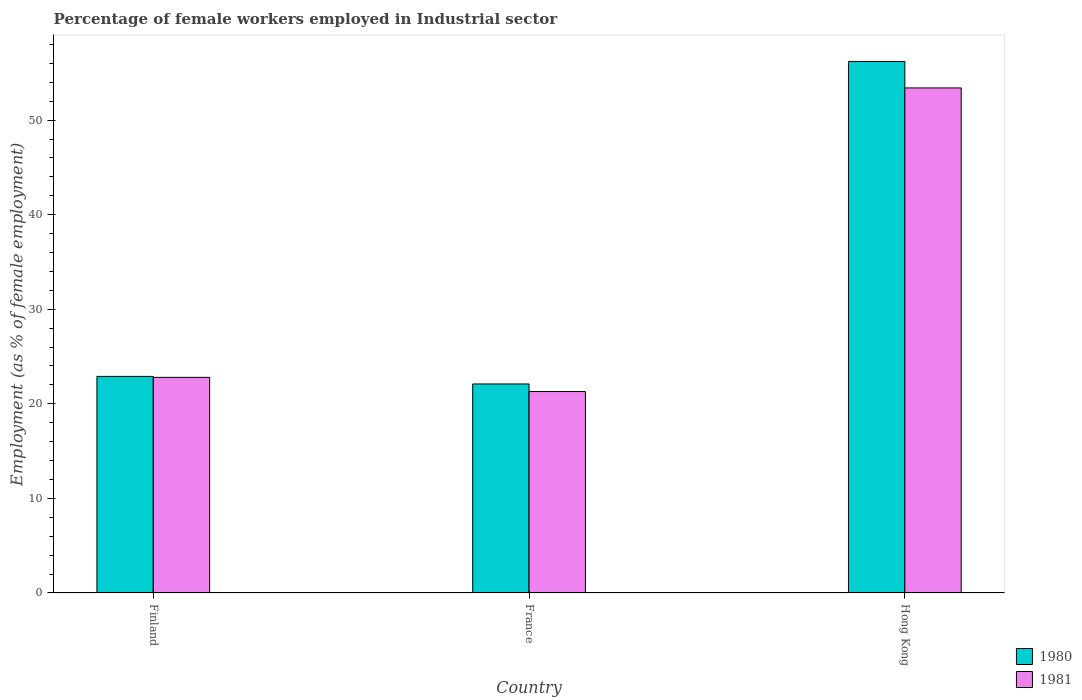How many bars are there on the 1st tick from the left?
Ensure brevity in your answer.  2. How many bars are there on the 1st tick from the right?
Keep it short and to the point. 2. In how many cases, is the number of bars for a given country not equal to the number of legend labels?
Ensure brevity in your answer.  0. What is the percentage of females employed in Industrial sector in 1981 in Finland?
Offer a very short reply. 22.8. Across all countries, what is the maximum percentage of females employed in Industrial sector in 1980?
Provide a short and direct response. 56.2. Across all countries, what is the minimum percentage of females employed in Industrial sector in 1981?
Offer a terse response. 21.3. In which country was the percentage of females employed in Industrial sector in 1981 maximum?
Offer a very short reply. Hong Kong. What is the total percentage of females employed in Industrial sector in 1980 in the graph?
Your response must be concise. 101.2. What is the difference between the percentage of females employed in Industrial sector in 1981 in France and that in Hong Kong?
Ensure brevity in your answer.  -32.1. What is the difference between the percentage of females employed in Industrial sector in 1980 in France and the percentage of females employed in Industrial sector in 1981 in Finland?
Your response must be concise. -0.7. What is the average percentage of females employed in Industrial sector in 1980 per country?
Keep it short and to the point. 33.73. What is the difference between the percentage of females employed in Industrial sector of/in 1980 and percentage of females employed in Industrial sector of/in 1981 in Hong Kong?
Your response must be concise. 2.8. In how many countries, is the percentage of females employed in Industrial sector in 1981 greater than 10 %?
Give a very brief answer. 3. What is the ratio of the percentage of females employed in Industrial sector in 1980 in Finland to that in Hong Kong?
Provide a short and direct response. 0.41. Is the percentage of females employed in Industrial sector in 1981 in Finland less than that in Hong Kong?
Provide a succinct answer. Yes. What is the difference between the highest and the second highest percentage of females employed in Industrial sector in 1981?
Offer a very short reply. -32.1. What is the difference between the highest and the lowest percentage of females employed in Industrial sector in 1981?
Your answer should be compact. 32.1. What does the 2nd bar from the left in France represents?
Your response must be concise. 1981. What does the 1st bar from the right in France represents?
Offer a terse response. 1981. How many bars are there?
Your answer should be compact. 6. Does the graph contain any zero values?
Your answer should be very brief. No. Does the graph contain grids?
Offer a terse response. No. What is the title of the graph?
Keep it short and to the point. Percentage of female workers employed in Industrial sector. Does "1963" appear as one of the legend labels in the graph?
Your answer should be very brief. No. What is the label or title of the Y-axis?
Offer a very short reply. Employment (as % of female employment). What is the Employment (as % of female employment) in 1980 in Finland?
Give a very brief answer. 22.9. What is the Employment (as % of female employment) of 1981 in Finland?
Make the answer very short. 22.8. What is the Employment (as % of female employment) of 1980 in France?
Offer a very short reply. 22.1. What is the Employment (as % of female employment) in 1981 in France?
Offer a terse response. 21.3. What is the Employment (as % of female employment) in 1980 in Hong Kong?
Keep it short and to the point. 56.2. What is the Employment (as % of female employment) in 1981 in Hong Kong?
Your response must be concise. 53.4. Across all countries, what is the maximum Employment (as % of female employment) in 1980?
Ensure brevity in your answer.  56.2. Across all countries, what is the maximum Employment (as % of female employment) in 1981?
Provide a short and direct response. 53.4. Across all countries, what is the minimum Employment (as % of female employment) in 1980?
Offer a very short reply. 22.1. Across all countries, what is the minimum Employment (as % of female employment) of 1981?
Offer a very short reply. 21.3. What is the total Employment (as % of female employment) of 1980 in the graph?
Your response must be concise. 101.2. What is the total Employment (as % of female employment) in 1981 in the graph?
Ensure brevity in your answer.  97.5. What is the difference between the Employment (as % of female employment) in 1980 in Finland and that in Hong Kong?
Ensure brevity in your answer.  -33.3. What is the difference between the Employment (as % of female employment) of 1981 in Finland and that in Hong Kong?
Ensure brevity in your answer.  -30.6. What is the difference between the Employment (as % of female employment) of 1980 in France and that in Hong Kong?
Ensure brevity in your answer.  -34.1. What is the difference between the Employment (as % of female employment) in 1981 in France and that in Hong Kong?
Provide a succinct answer. -32.1. What is the difference between the Employment (as % of female employment) of 1980 in Finland and the Employment (as % of female employment) of 1981 in France?
Your response must be concise. 1.6. What is the difference between the Employment (as % of female employment) in 1980 in Finland and the Employment (as % of female employment) in 1981 in Hong Kong?
Give a very brief answer. -30.5. What is the difference between the Employment (as % of female employment) of 1980 in France and the Employment (as % of female employment) of 1981 in Hong Kong?
Your response must be concise. -31.3. What is the average Employment (as % of female employment) in 1980 per country?
Keep it short and to the point. 33.73. What is the average Employment (as % of female employment) in 1981 per country?
Offer a terse response. 32.5. What is the ratio of the Employment (as % of female employment) of 1980 in Finland to that in France?
Keep it short and to the point. 1.04. What is the ratio of the Employment (as % of female employment) in 1981 in Finland to that in France?
Make the answer very short. 1.07. What is the ratio of the Employment (as % of female employment) in 1980 in Finland to that in Hong Kong?
Provide a succinct answer. 0.41. What is the ratio of the Employment (as % of female employment) of 1981 in Finland to that in Hong Kong?
Keep it short and to the point. 0.43. What is the ratio of the Employment (as % of female employment) in 1980 in France to that in Hong Kong?
Ensure brevity in your answer.  0.39. What is the ratio of the Employment (as % of female employment) of 1981 in France to that in Hong Kong?
Your response must be concise. 0.4. What is the difference between the highest and the second highest Employment (as % of female employment) of 1980?
Give a very brief answer. 33.3. What is the difference between the highest and the second highest Employment (as % of female employment) in 1981?
Provide a short and direct response. 30.6. What is the difference between the highest and the lowest Employment (as % of female employment) of 1980?
Your answer should be compact. 34.1. What is the difference between the highest and the lowest Employment (as % of female employment) in 1981?
Your response must be concise. 32.1. 